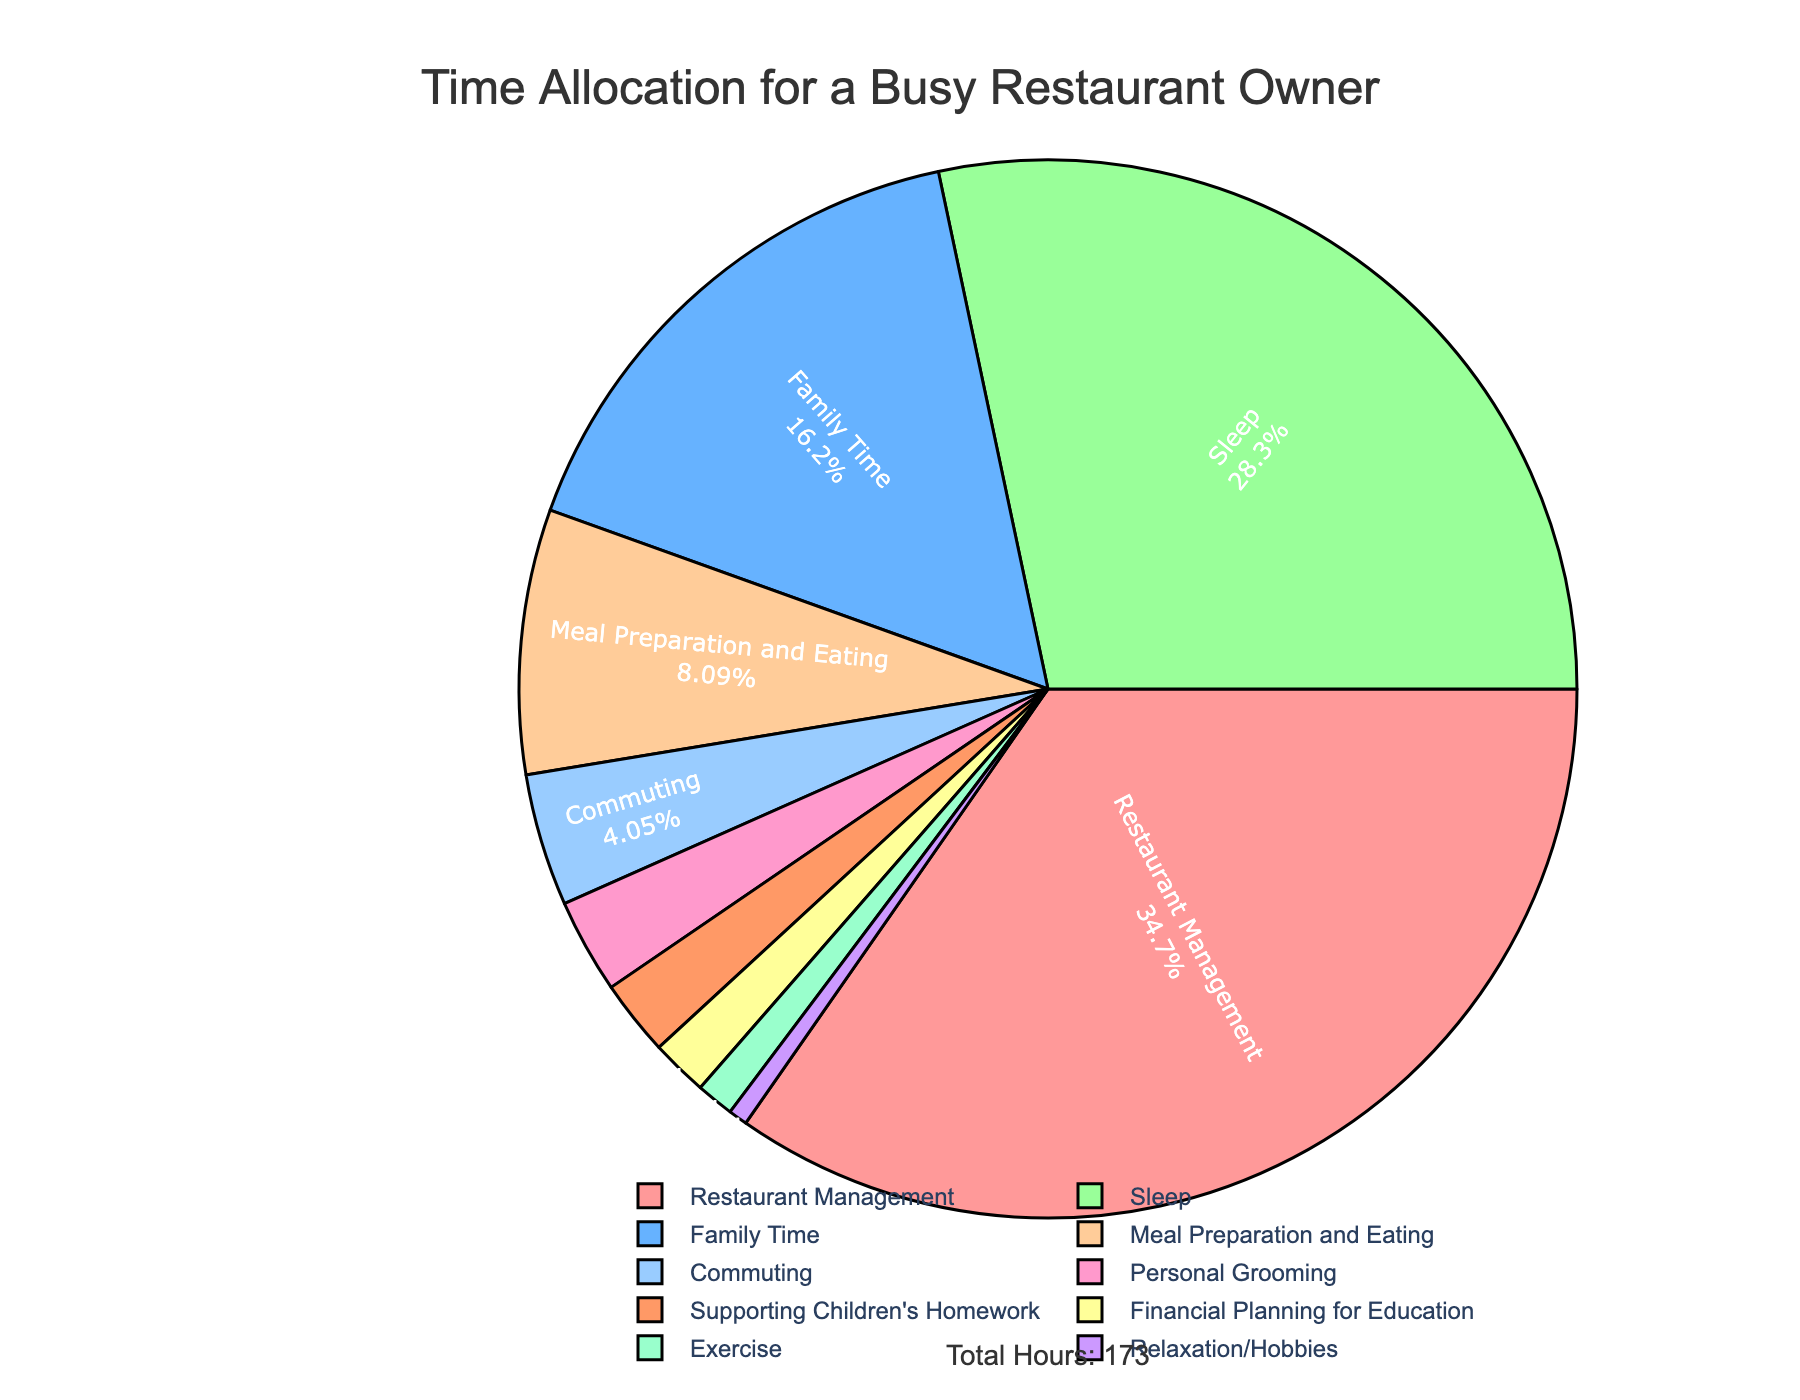What percentage of time is spent on restaurant management? Restaurant Management occupies 60 hours out of the total 173 hours. The percentage is calculated as (60/173) * 100, which is approximately 34.68%.
Answer: 34.68% How much more time is spent on family time compared to exercise? The time spent on family time is 28 hours, and on exercise is 2 hours. The difference is 28 - 2 = 26 hours.
Answer: 26 hours Which activity takes up the least amount of time? The chart shows that Relaxation/Hobbies is the activity with the smallest slice, indicating that it takes up the least amount of time, which is 1 hour.
Answer: Relaxation/Hobbies What is the combined percentage of time spent on sleep and commuting? Sleep and Commuting together take up 49 and 7 hours respectively, totaling 56 hours. The combined percentage is (56/173) * 100, which is approximately 32.37%.
Answer: 32.37% How does the time allocated to meal preparation and eating compare to personal grooming? Meal Preparation and Eating takes 14 hours, while Personal Grooming takes 5 hours. Meal Preparation and Eating occupies more time by 14 - 5 = 9 hours.
Answer: 9 hours What is the total time spent on activities related to family (Family Time and Supporting Children's Homework)? Family Time is 28 hours and Supporting Children's Homework is 4 hours. The sum is 28 + 4 = 32 hours.
Answer: 32 hours What percentage of time is dedicated to financial planning for education? Financial Planning for Education occupies 3 hours out of the total 173 hours. The percentage is calculated as (3/173) * 100, which is approximately 1.73%.
Answer: 1.73% Among Meal Preparation and Eating, Commuting, and Exercise, which activity has the largest duration? Meal Preparation and Eating has the largest duration among the three with 14 hours, compared to Commuting (7 hours) and Exercise (2 hours).
Answer: Meal Preparation and Eating How much more time is spent on sleep than on personal grooming and exercise combined? Sleep takes 49 hours, while Personal Grooming and Exercise together take 5 + 2 = 7 hours. The difference is 49 - 7 = 42 hours.
Answer: 42 hours 